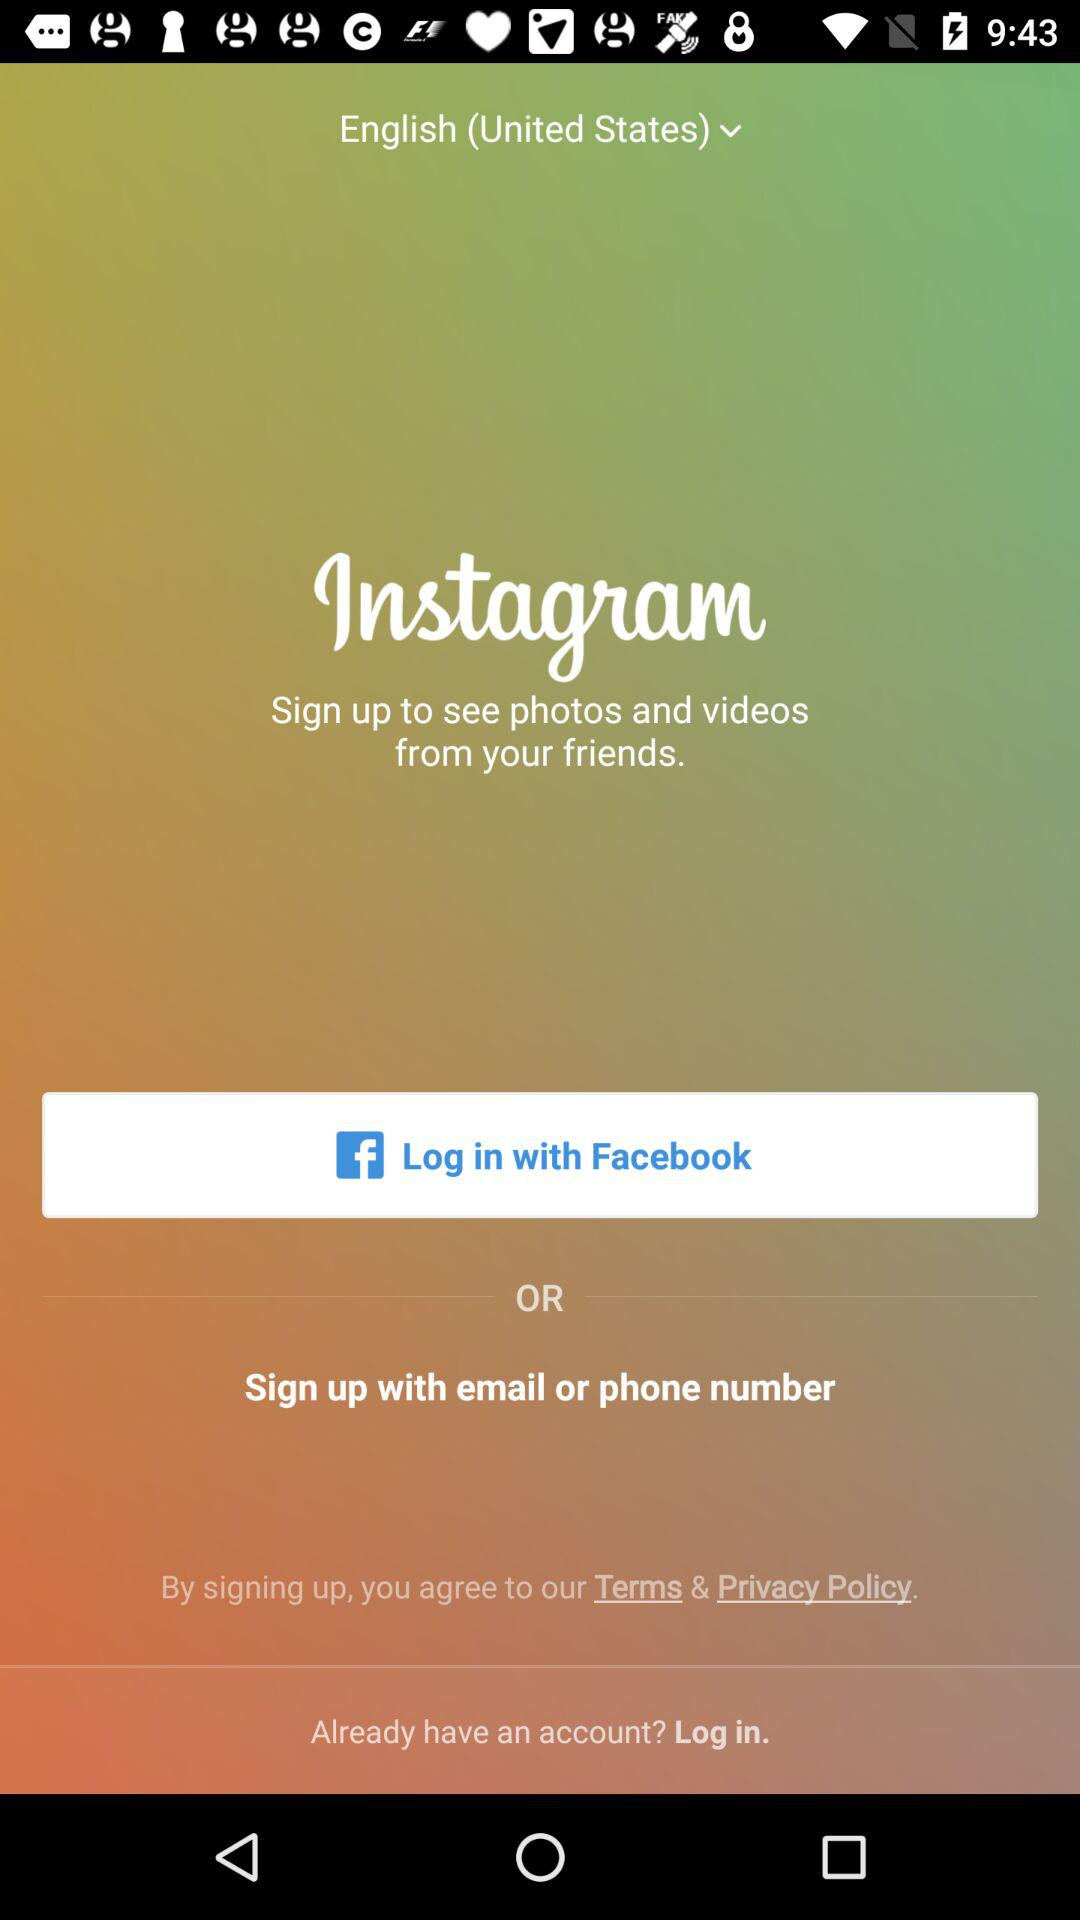What account should I choose to sign in with? The accounts you can choose to login with are "Facebook", "email" and "phone number". 